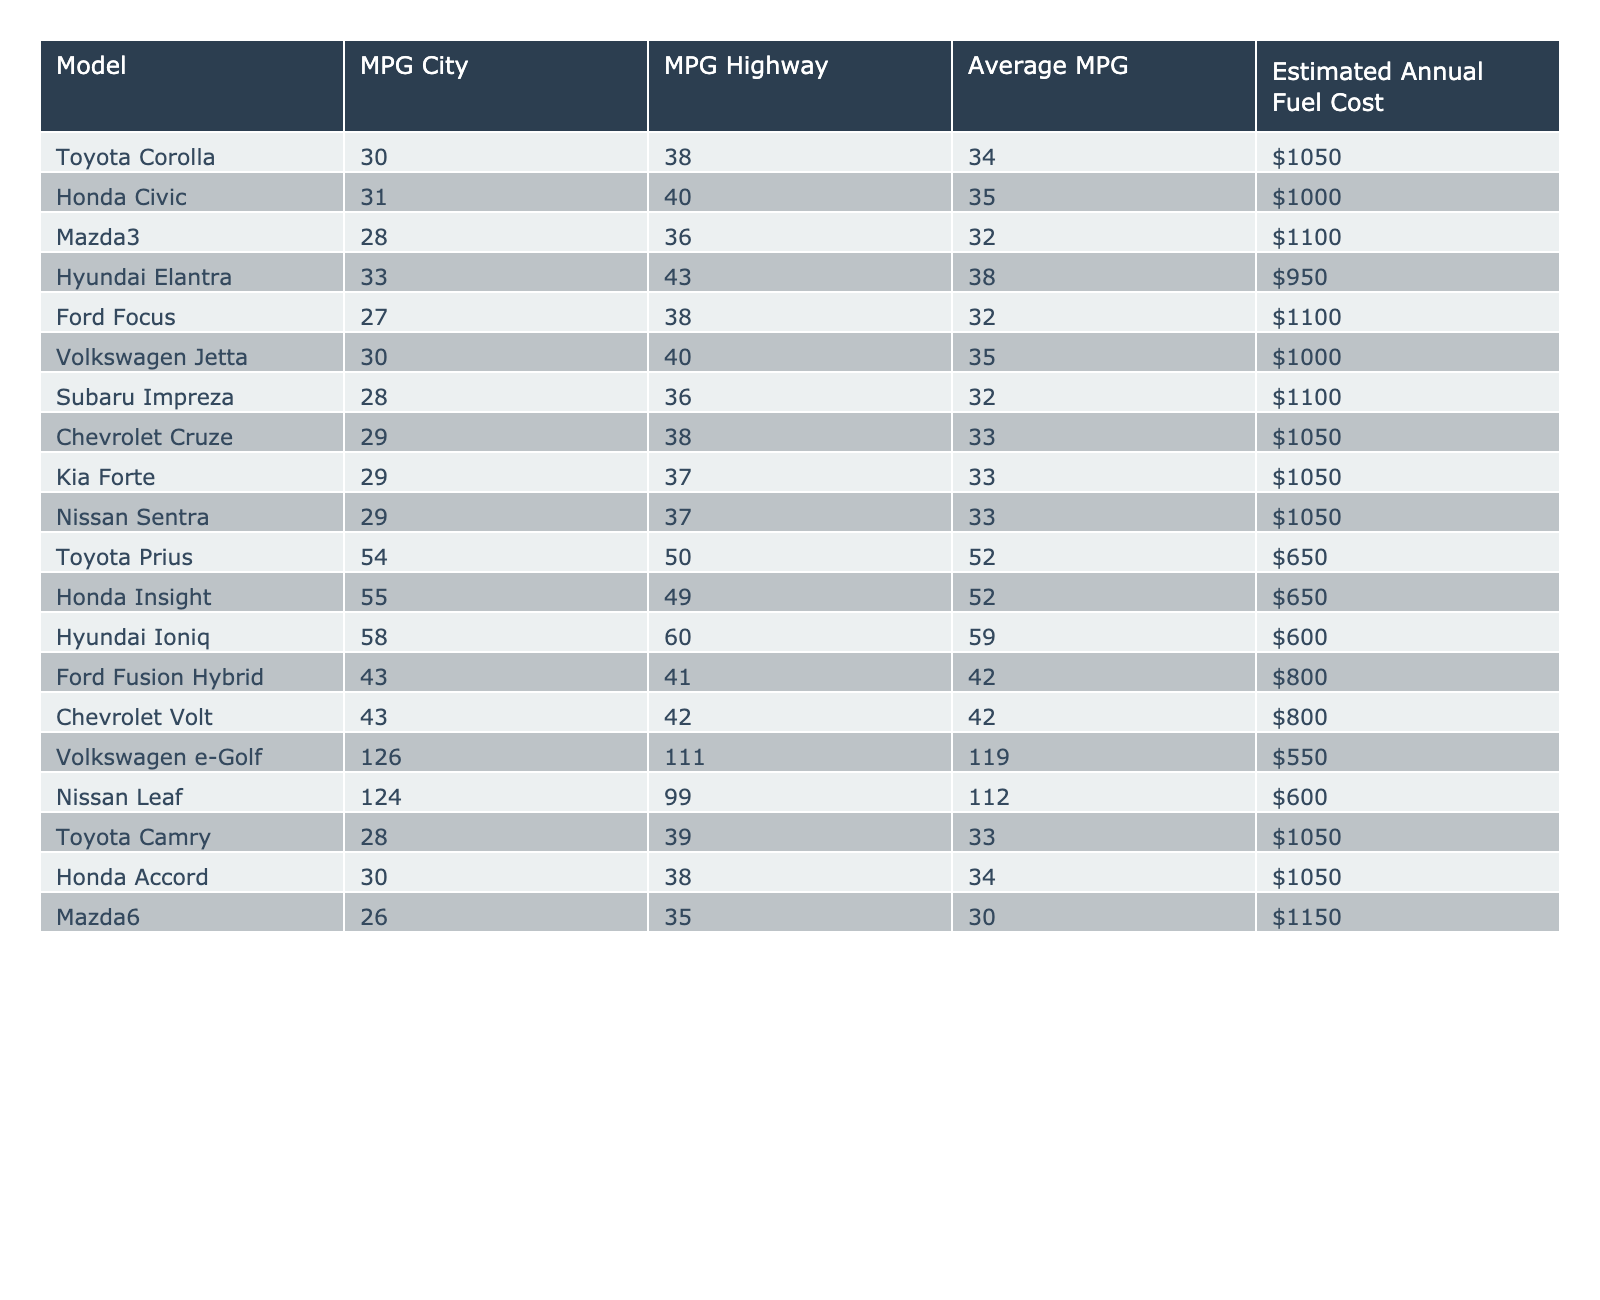What is the fuel efficiency (MPG) of the Honda Civic in the city? The table shows that the MPG City for the Honda Civic is listed as 31.
Answer: 31 Which car has the lowest estimated annual fuel cost? By comparing the Estimated Annual Fuel Cost for each model, the Hyundai Ioniq has the lowest at $600.
Answer: $600 What is the average fuel efficiency of the Ford Fusion Hybrid and Chevrolet Volt? The Average MPG for Ford Fusion Hybrid is 42 and for Chevrolet Volt it is also 42, so the average is (42 + 42) / 2 = 42.
Answer: 42 True or False: The Toyota Prius has a better highway MPG than the Mazda3. The highway MPG for the Toyota Prius is 50, while the Mazda3 is 36, so the statement is true.
Answer: True Which model has the highest Average MPG and what is that MPG? By observing the Average MPG column, the highest is for the Hyundai Ioniq with 59 MPG.
Answer: 59 What is the difference in estimated annual fuel costs between the Volkswagen e-Golf and Nissan Leaf? The Estimated Annual Fuel Cost for the Volkswagen e-Golf is $550 and for the Nissan Leaf is $600. The difference is $600 - $550 = $50.
Answer: $50 How many car models have an average MPG greater than 35? From the table, the models with Average MPG greater than 35 are the Hyundai Elantra, Toyota Prius, Honda Insight, and Hyundai Ioniq. There are 4 such models.
Answer: 4 What is the average MPG of all the sedans (considering only sedans) listed in the table? Adding the Average MPG for each sedan: (34 + 35 + 32 + 33 + 33 + 33 + 33 + 34 + 30 + 33) = 330. There are 10 sedans, so the average is 330 / 10 = 33.
Answer: 33 Do any models exceed 40 MPG in the city? Based on the table, both the Toyota Prius and Honda Insight exceed 40 MPG in the city (54 and 55, respectively). Thus, the answer is yes.
Answer: Yes Which model has the best city MPG and what is that MPG? The best city MPG is for the Hyundai Ioniq at 58 MPG.
Answer: 58 